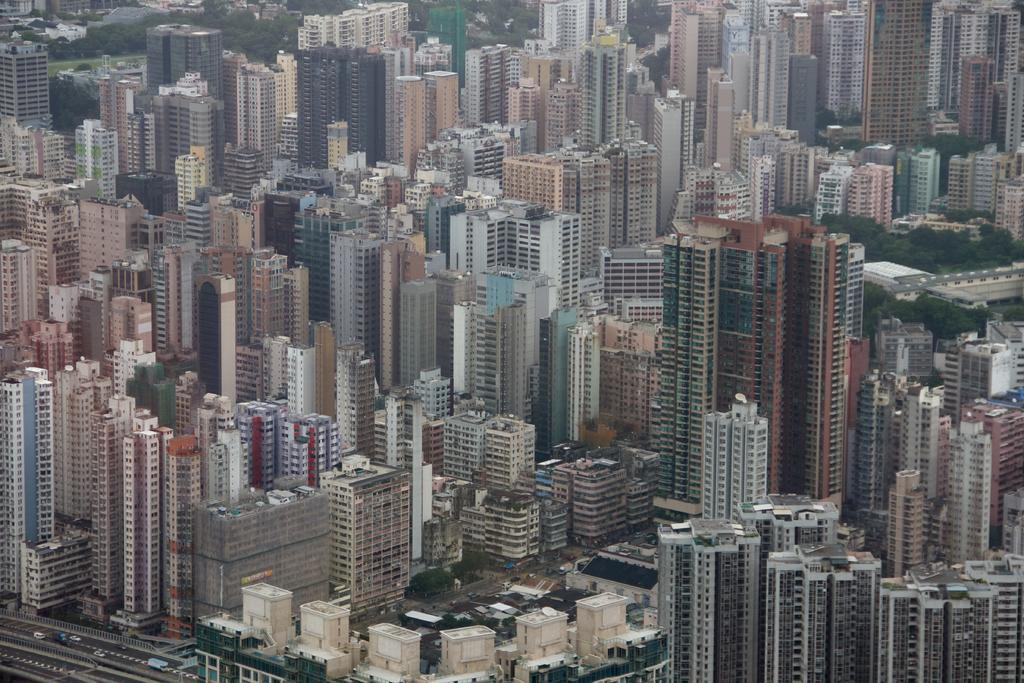What type of structures are visible in the image? There are skyscrapers and buildings in the image. What else can be seen in the image besides structures? There are trees and ground visible in the image. What type of transportation is present on the road in the image? Motor vehicles are present on the road in the image. What type of face can be seen on the skyscraper in the image? There is no face visible on the skyscraper in the image. 